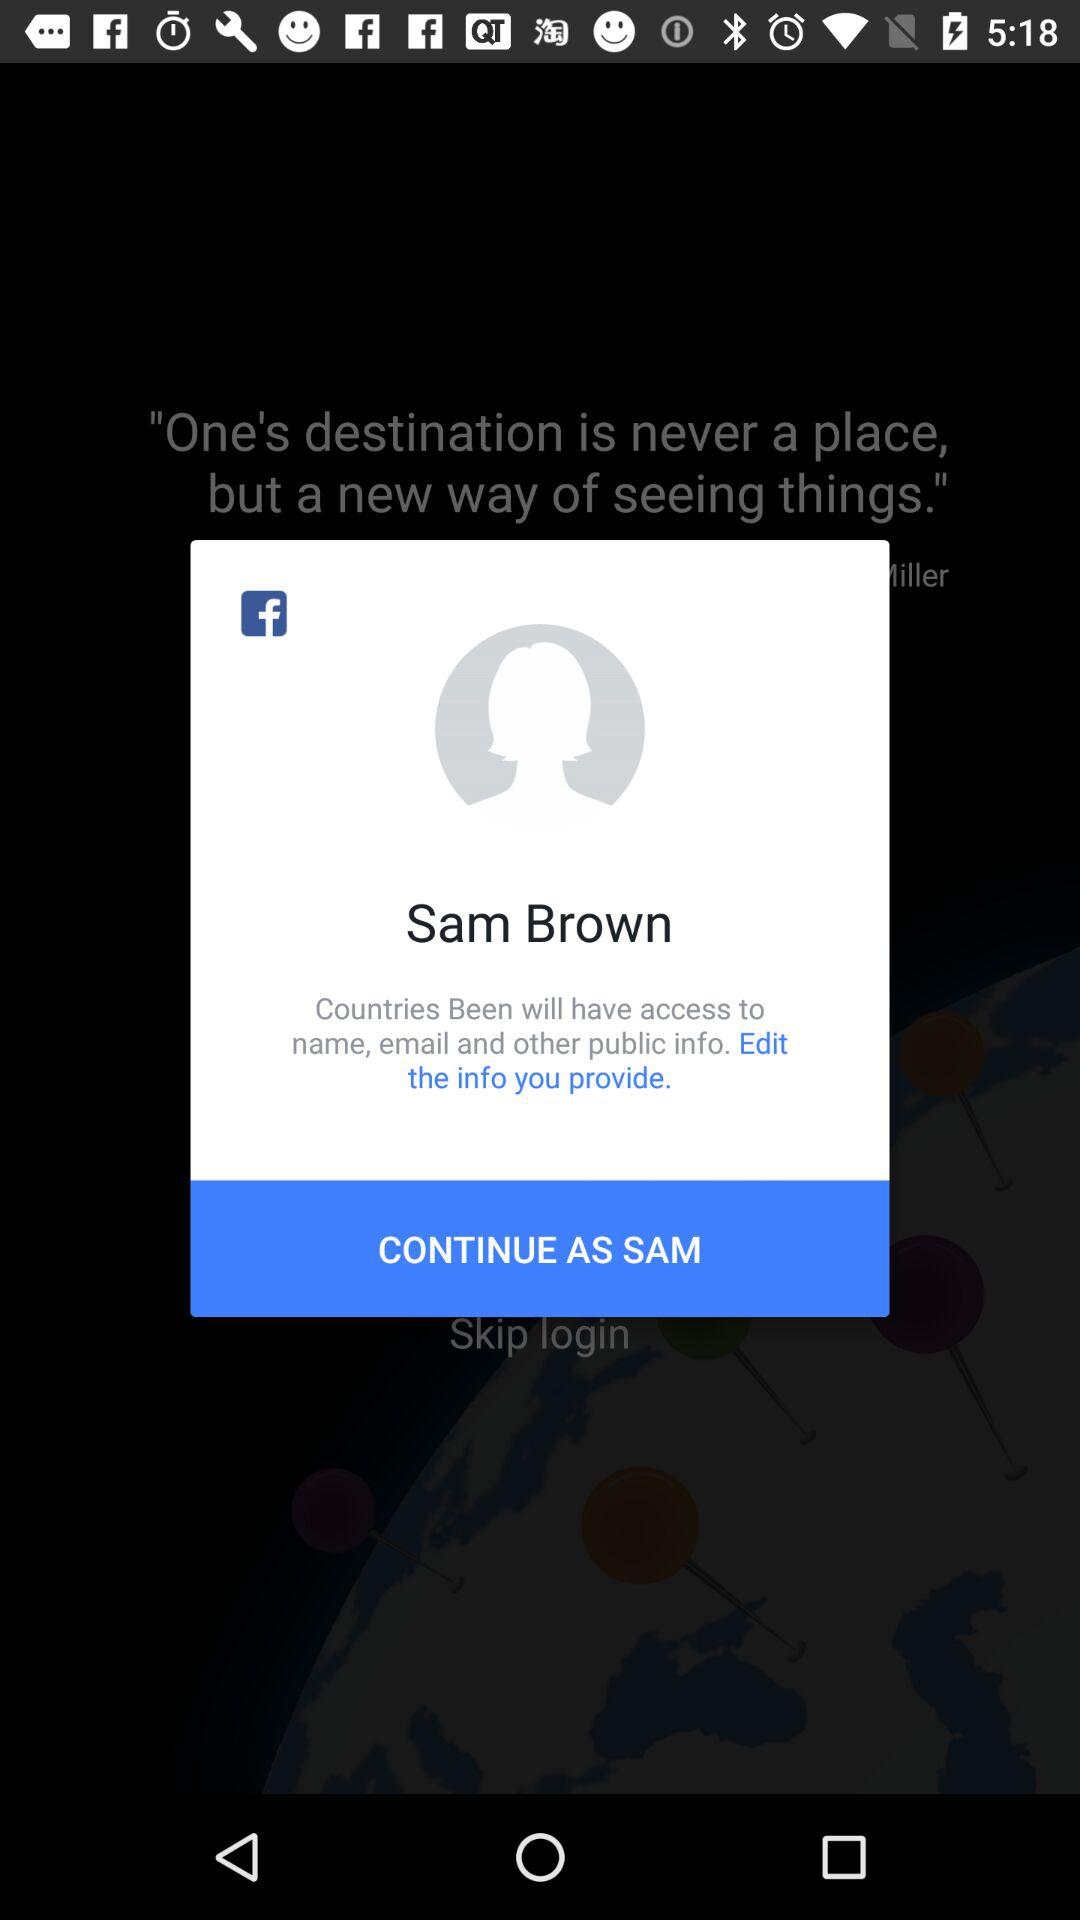Who is this application powered by?
When the provided information is insufficient, respond with <no answer>. <no answer> 